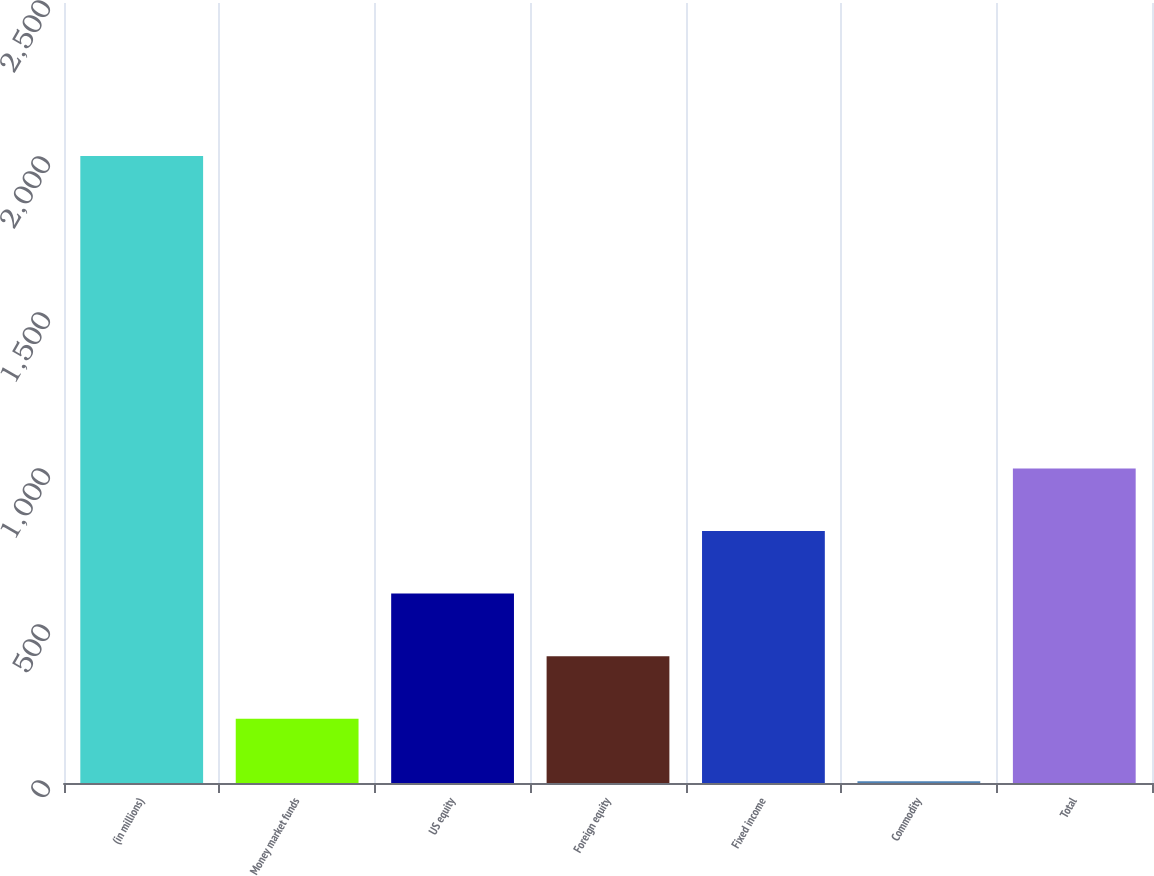Convert chart to OTSL. <chart><loc_0><loc_0><loc_500><loc_500><bar_chart><fcel>(in millions)<fcel>Money market funds<fcel>US equity<fcel>Foreign equity<fcel>Fixed income<fcel>Commodity<fcel>Total<nl><fcel>2010<fcel>206.22<fcel>607.06<fcel>406.64<fcel>807.48<fcel>5.8<fcel>1007.9<nl></chart> 